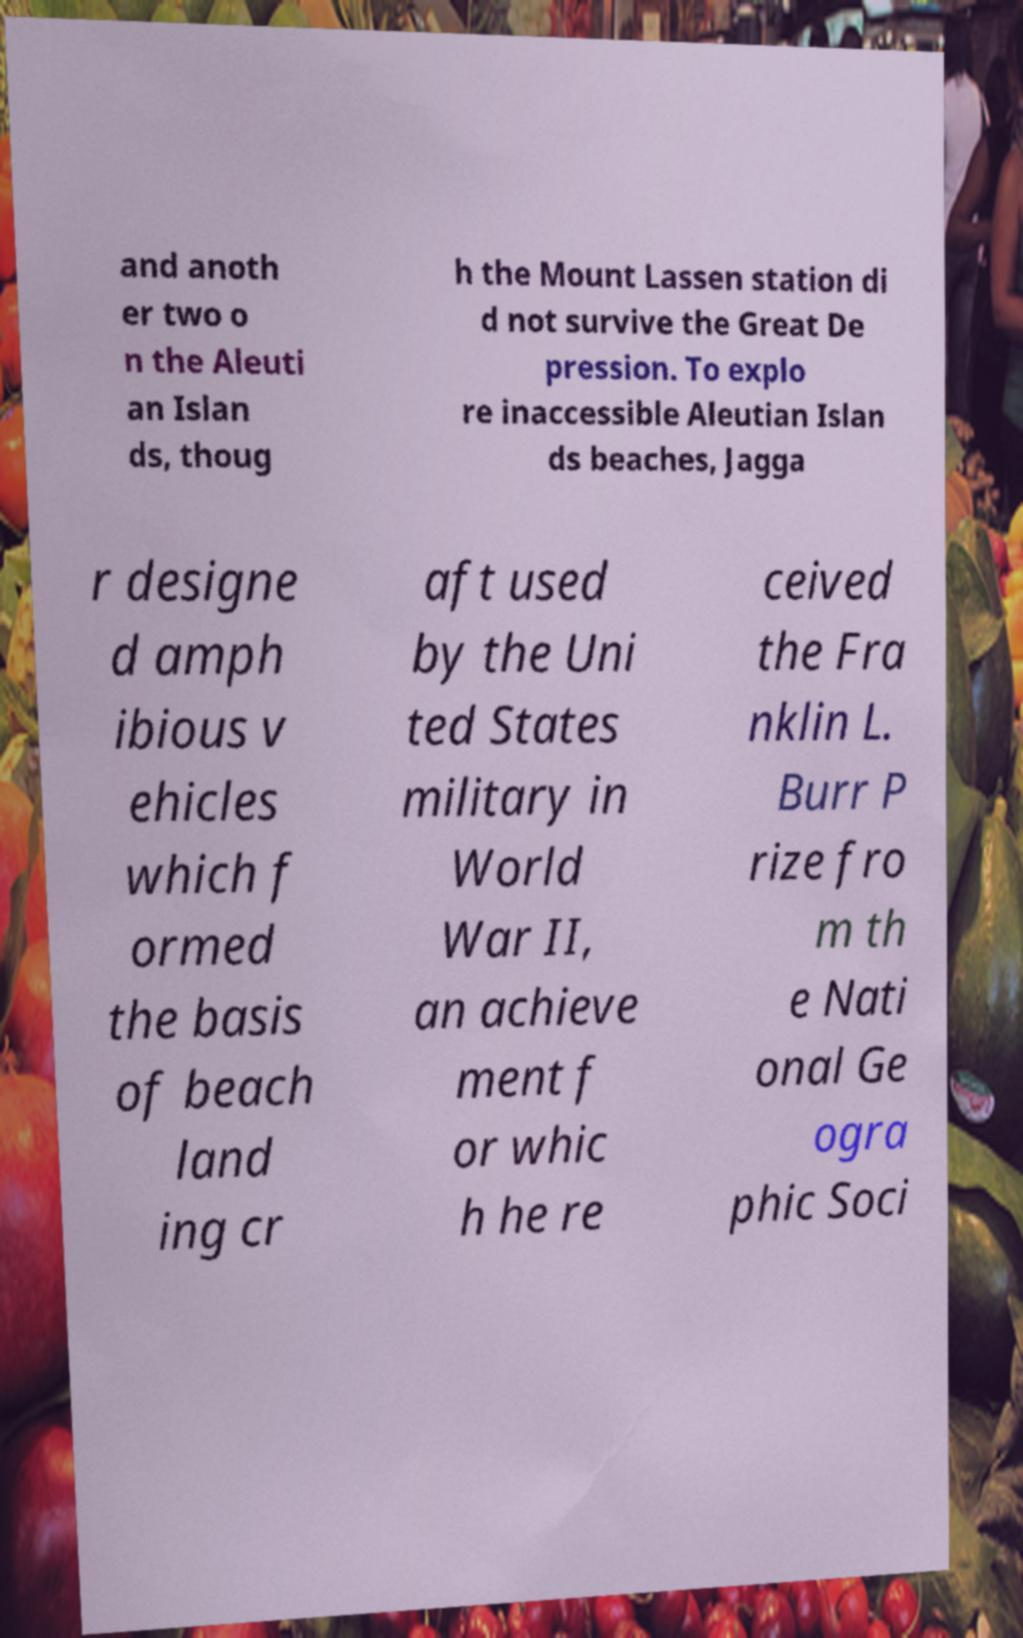Can you read and provide the text displayed in the image?This photo seems to have some interesting text. Can you extract and type it out for me? and anoth er two o n the Aleuti an Islan ds, thoug h the Mount Lassen station di d not survive the Great De pression. To explo re inaccessible Aleutian Islan ds beaches, Jagga r designe d amph ibious v ehicles which f ormed the basis of beach land ing cr aft used by the Uni ted States military in World War II, an achieve ment f or whic h he re ceived the Fra nklin L. Burr P rize fro m th e Nati onal Ge ogra phic Soci 